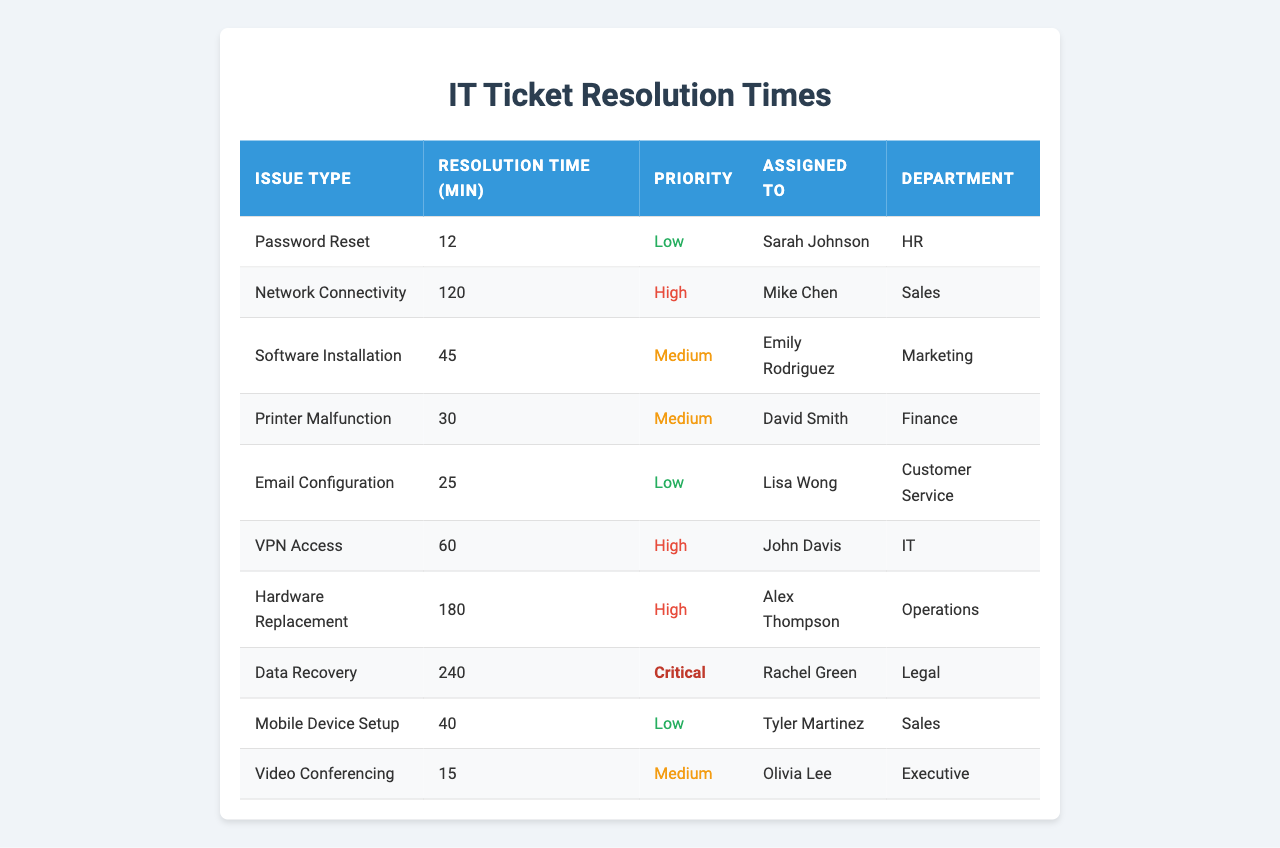What is the resolution time for "VPN Access"? The table shows that "VPN Access" has a resolution time of 60 minutes.
Answer: 60 Who is assigned to handle "Data Recovery"? The table indicates that "Data Recovery" is assigned to Rachel Green.
Answer: Rachel Green Which issue type has the highest resolution time? The highest resolution time is 240 minutes for "Data Recovery".
Answer: Data Recovery How many issues have a high priority? The issues with high priority are "Network Connectivity," "VPN Access," and "Hardware Replacement," totaling 3 high-priority issues.
Answer: 3 What is the average resolution time for all issues listed? The total resolution time is 12 + 120 + 45 + 30 + 25 + 60 + 180 + 240 + 40 + 15 = 832 minutes. There are 10 issues; thus, the average resolution time is 832/10 = 83.2 minutes.
Answer: 83.2 Is there any issue with a critical priority? Yes, "Data Recovery" is marked as critical priority.
Answer: Yes What is the total resolution time for medium priority issues? The medium priority issues, "Software Installation," "Printer Malfunction," and "Video Conferencing," have resolution times of 45, 30, and 15 minutes, respectively. The total is 45 + 30 + 15 = 90 minutes.
Answer: 90 Which department has the longest resolution time for their IT issues? The "Legal" department's issue, "Data Recovery," has the longest resolution time at 240 minutes, which is longer than any other department's issue.
Answer: Legal What is the difference in resolution time between the lowest and highest priority issues? The lowest resolution time (for "Password Reset") is 12 minutes, while the highest resolution time (for "Data Recovery") is 240 minutes. The difference is 240 - 12 = 228 minutes.
Answer: 228 How many different issue types were resolved in less than 30 minutes? The table shows that only "Password Reset" (12 minutes) and "Video Conferencing" (15 minutes) were resolved in less than 30 minutes, totaling 2 issue types.
Answer: 2 